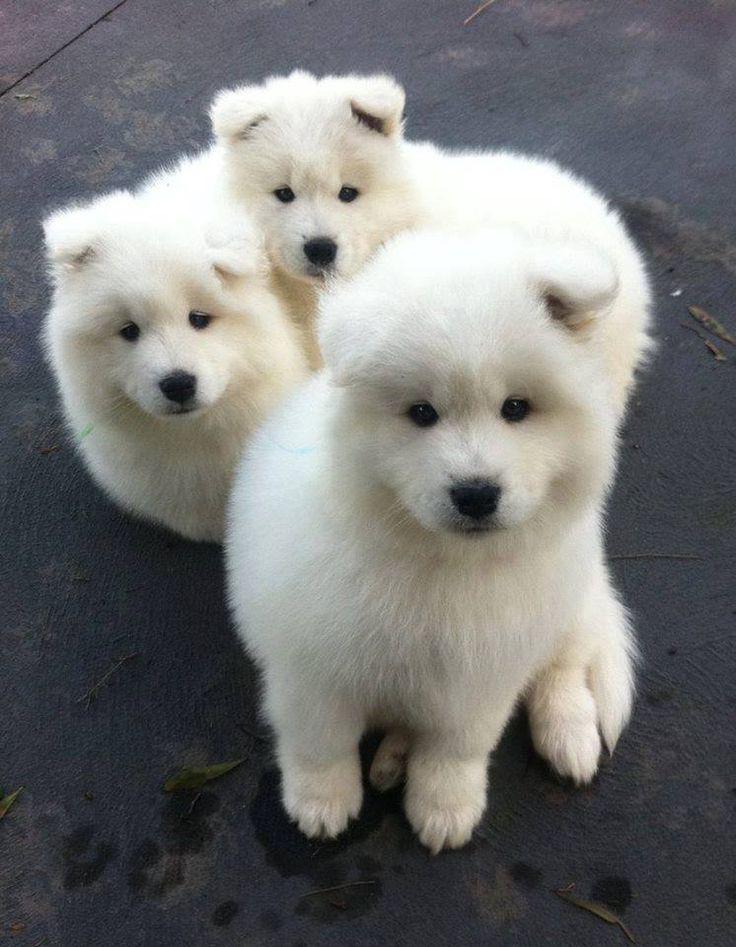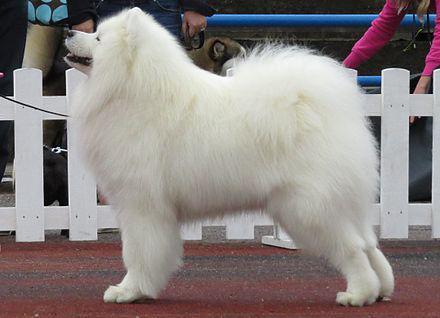The first image is the image on the left, the second image is the image on the right. Considering the images on both sides, is "One image shows a reclining white dog chewing on something." valid? Answer yes or no. No. The first image is the image on the left, the second image is the image on the right. For the images shown, is this caption "One of the images show a single dog standing on all four legs." true? Answer yes or no. Yes. 